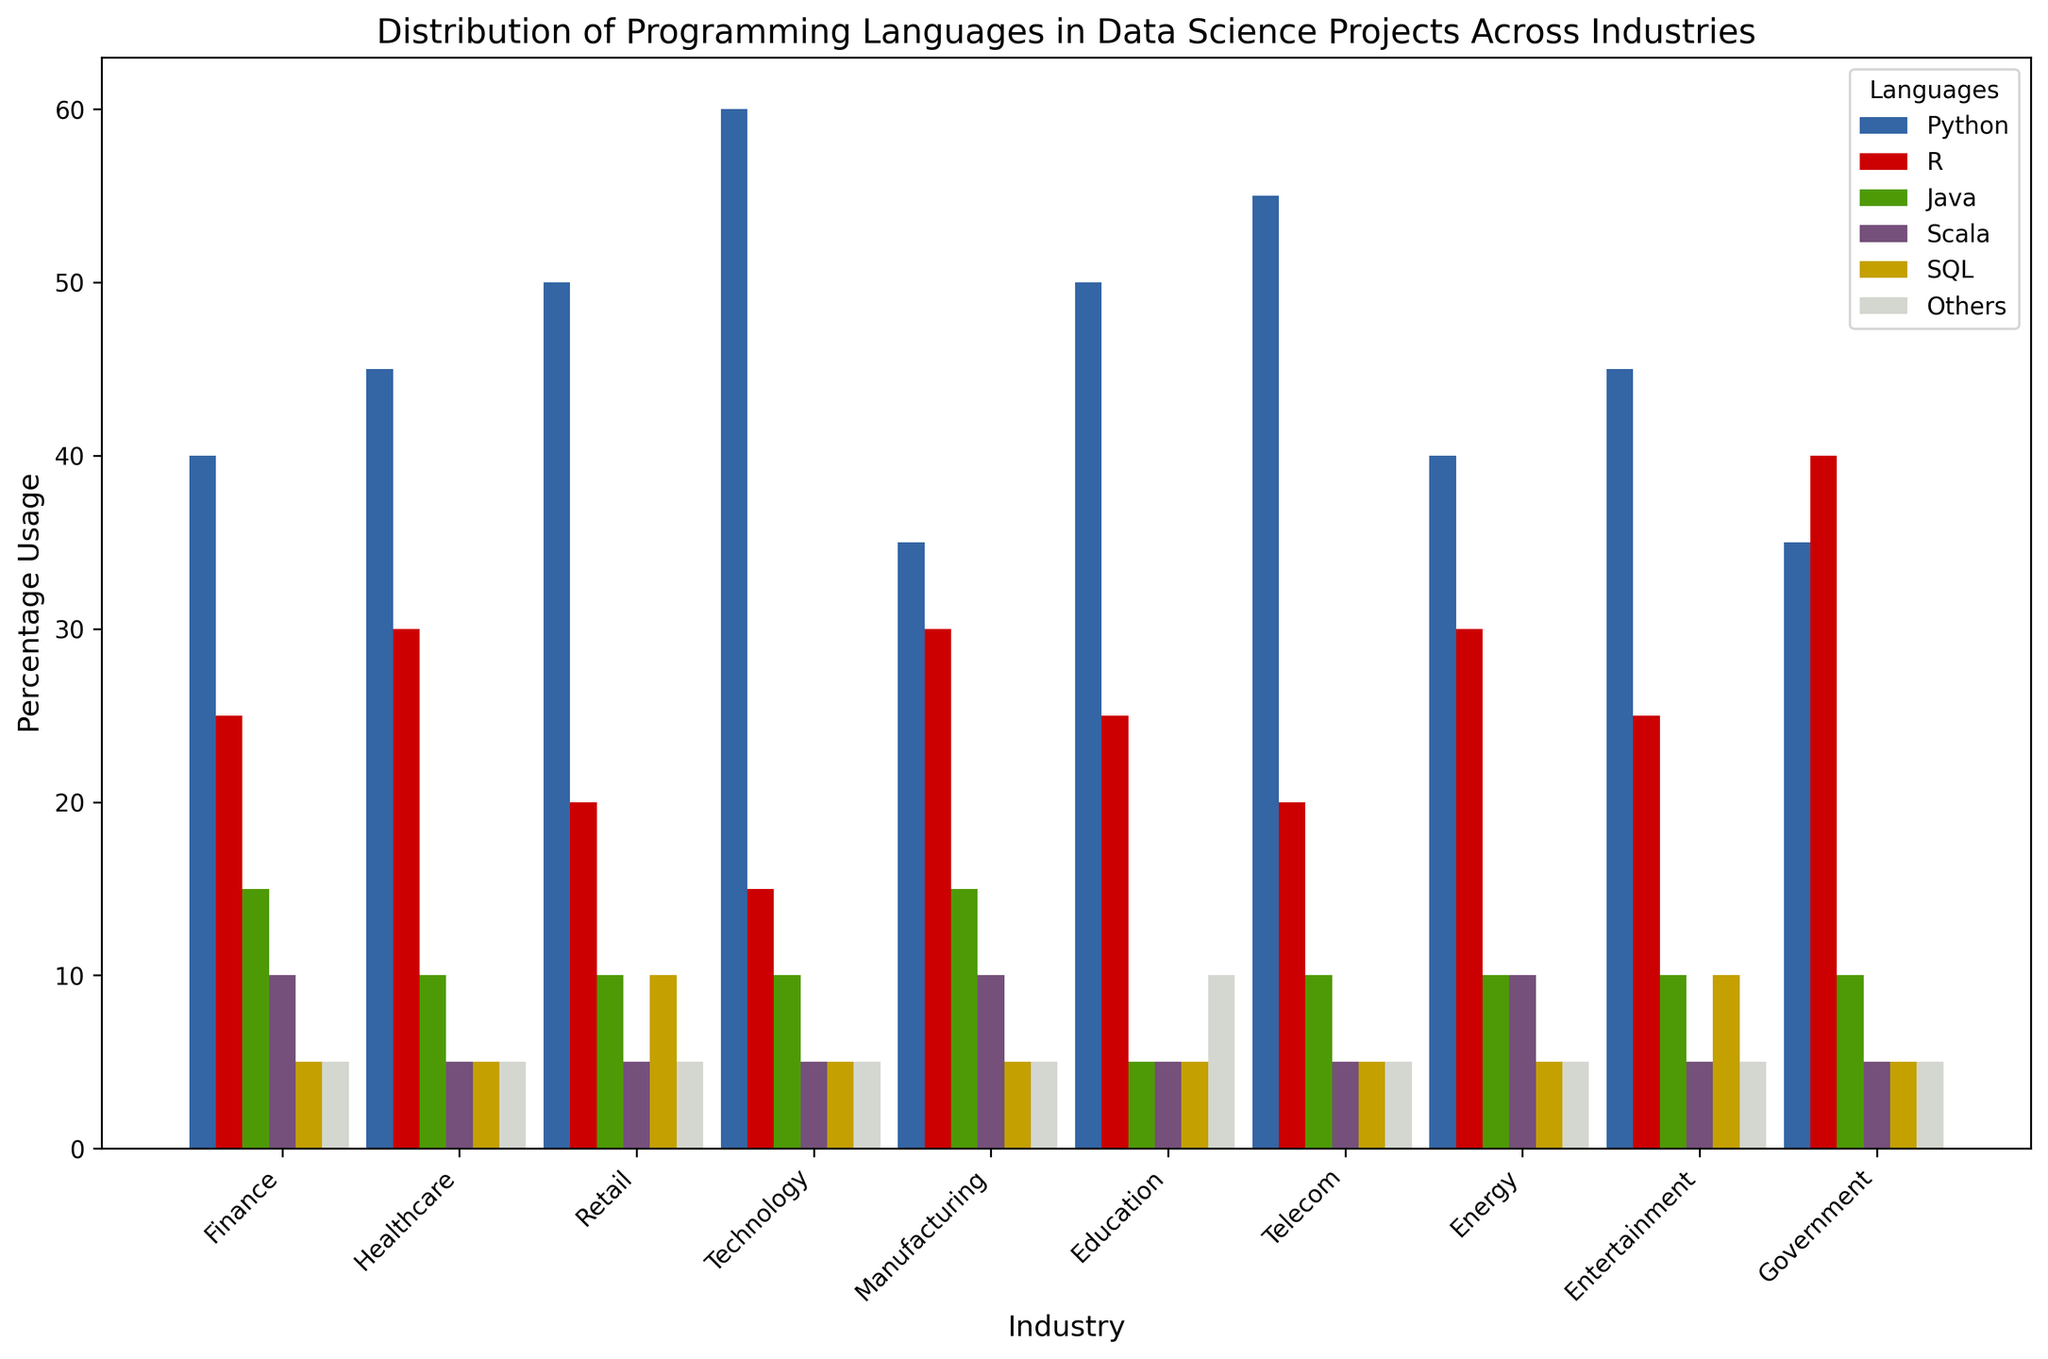Which industry uses Python the most? By examining the figure, we can compare the height of the bars for Python across all industries. The Technology industry has the tallest bar for Python.
Answer: Technology What is the combined usage percentage of Java and SQL in the Finance industry? First find the percentages for Java and SQL in the Finance industry which are 15% and 5%, respectively, then sum them up: 15 + 5 = 20.
Answer: 20 How does the usage of R compare between the Healthcare and Government industries? From the figure, the height of the bars for R in Healthcare and Government industries show 30% and 40%, respectively. The Government industry uses R more.
Answer: Government is higher Among all industries, which has the least area of usage indicated by the bar for Scala? Compare the heights of the bars for Scala across all industries. Education, Healthcare, Retail, Technology, Telecom, Entertainment, and Government all have the shortest bar for Scala.
Answer: Education, Healthcare, Retail, Technology, Telecom, Entertainment, Government What is the average percentage mentioned on the bars in all industries for the language Python? Add the heights of the bars for Python in all industries and divide by the number of industries: (40 + 45 + 50 + 60 + 35 + 50 + 55 + 40 + 45 + 35)/10 = 49.5.
Answer: 49.5 Compare the combined usage of 'Others' in Education and Manufacturing industries. Which one is higher? From the figure, find the heights of the bars for 'Others' in Education and Manufacturing which are 10% and 5%, respectively. The Education industry has a higher combined usage.
Answer: Education What is the total percentage share of SQL in all industries? Sum the heights of the bars for SQL in all industries: 5 + 5 + 10 + 5 + 5 + 5 + 5 + 5 + 10 + 5 = 60.
Answer: 60 In which industry does Python surpass the combined percentage usage of Java and Scala the most? Identify the industries where the difference between Python and the sum of Java and Scala is the greatest. For each industry, calculate Python - (Java + Scala). Python surpasses them the most in the Technology industry: 60 - (10 + 5) = 45.
Answer: Technology 